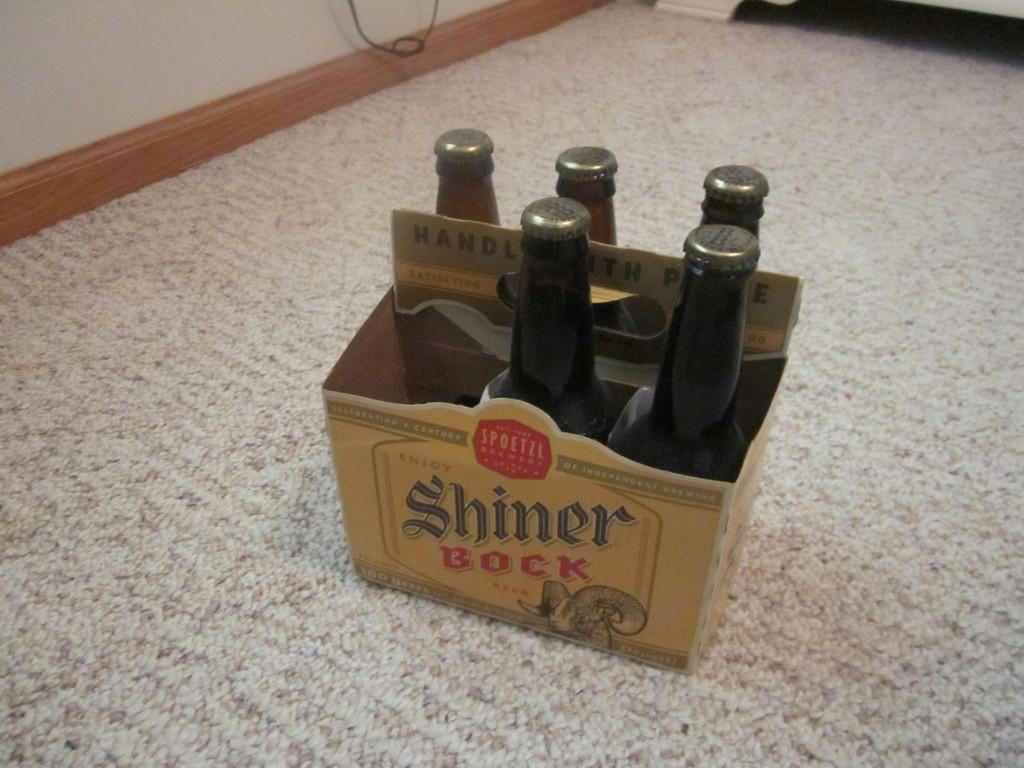<image>
Share a concise interpretation of the image provided. A six-pack of Shiner Bock has one bottle missing. 